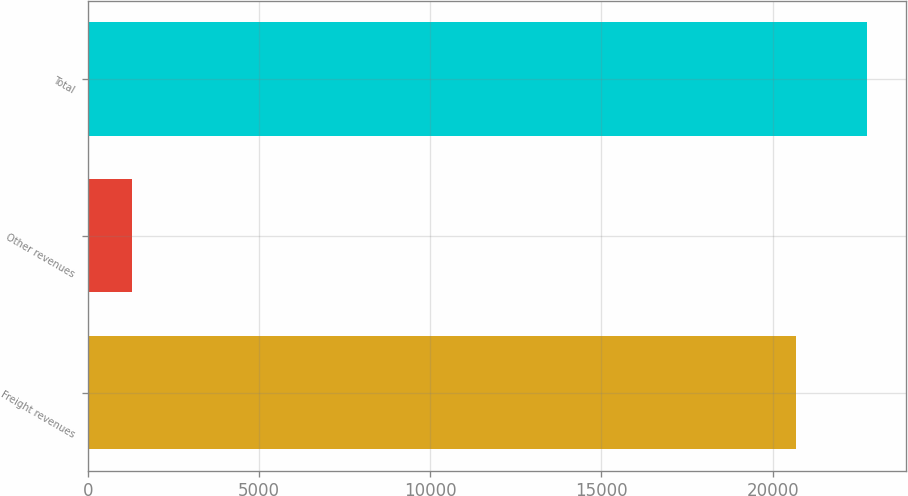Convert chart. <chart><loc_0><loc_0><loc_500><loc_500><bar_chart><fcel>Freight revenues<fcel>Other revenues<fcel>Total<nl><fcel>20684<fcel>1279<fcel>22752.4<nl></chart> 